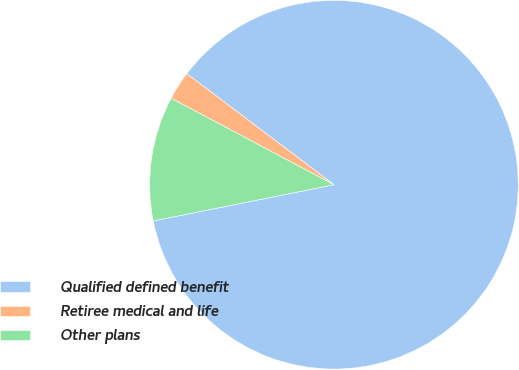<chart> <loc_0><loc_0><loc_500><loc_500><pie_chart><fcel>Qualified defined benefit<fcel>Retiree medical and life<fcel>Other plans<nl><fcel>86.56%<fcel>2.52%<fcel>10.92%<nl></chart> 